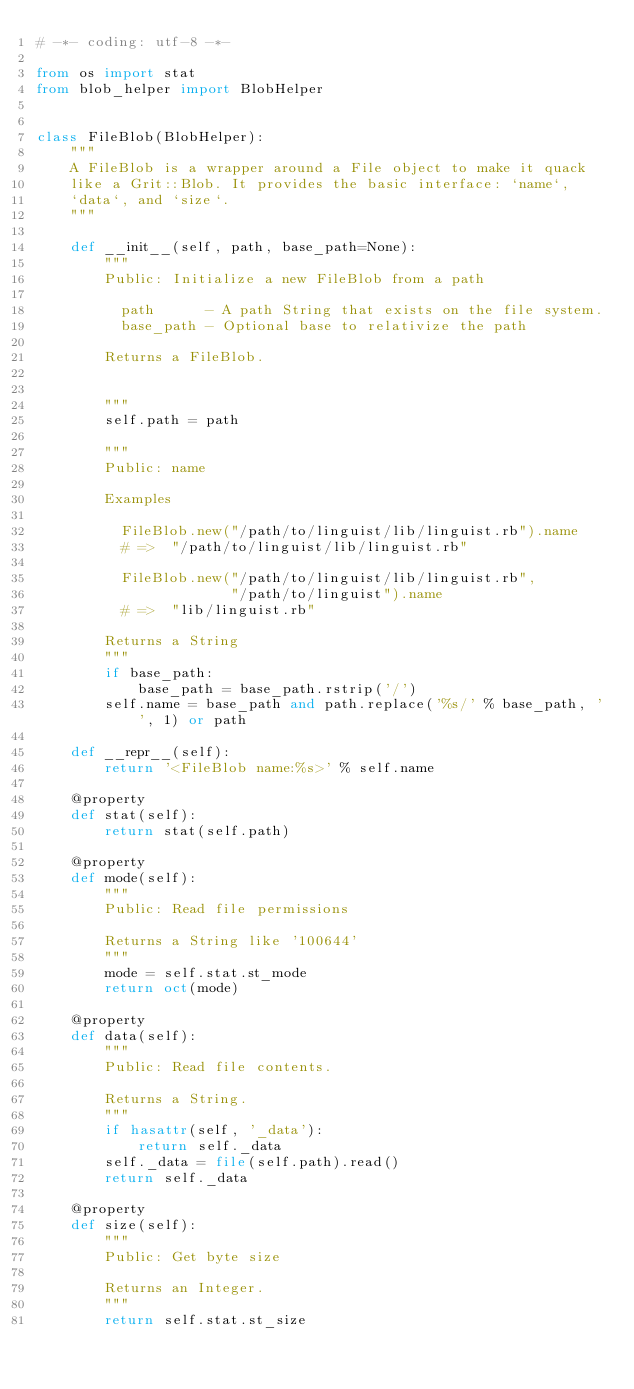<code> <loc_0><loc_0><loc_500><loc_500><_Python_># -*- coding: utf-8 -*-

from os import stat
from blob_helper import BlobHelper


class FileBlob(BlobHelper):
    """
    A FileBlob is a wrapper around a File object to make it quack
    like a Grit::Blob. It provides the basic interface: `name`,
    `data`, and `size`.
    """

    def __init__(self, path, base_path=None):
        """
        Public: Initialize a new FileBlob from a path

          path      - A path String that exists on the file system.
          base_path - Optional base to relativize the path

        Returns a FileBlob.


        """
        self.path = path

        """
        Public: name

        Examples

          FileBlob.new("/path/to/linguist/lib/linguist.rb").name
          # =>  "/path/to/linguist/lib/linguist.rb"

          FileBlob.new("/path/to/linguist/lib/linguist.rb",
                       "/path/to/linguist").name
          # =>  "lib/linguist.rb"

        Returns a String
        """
        if base_path:
            base_path = base_path.rstrip('/')
        self.name = base_path and path.replace('%s/' % base_path, '', 1) or path

    def __repr__(self):
        return '<FileBlob name:%s>' % self.name

    @property
    def stat(self):
        return stat(self.path)

    @property
    def mode(self):
        """
        Public: Read file permissions

        Returns a String like '100644'
        """
        mode = self.stat.st_mode
        return oct(mode)

    @property
    def data(self):
        """
        Public: Read file contents.

        Returns a String.
        """
        if hasattr(self, '_data'):
            return self._data
        self._data = file(self.path).read()
        return self._data

    @property
    def size(self):
        """
        Public: Get byte size

        Returns an Integer.
        """
        return self.stat.st_size
</code> 